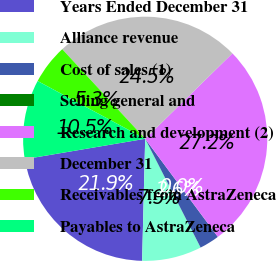<chart> <loc_0><loc_0><loc_500><loc_500><pie_chart><fcel>Years Ended December 31<fcel>Alliance revenue<fcel>Cost of sales (1)<fcel>Selling general and<fcel>Research and development (2)<fcel>December 31<fcel>Receivables from AstraZeneca<fcel>Payables to AstraZeneca<nl><fcel>21.93%<fcel>7.9%<fcel>2.64%<fcel>0.01%<fcel>27.18%<fcel>24.55%<fcel>5.27%<fcel>10.52%<nl></chart> 